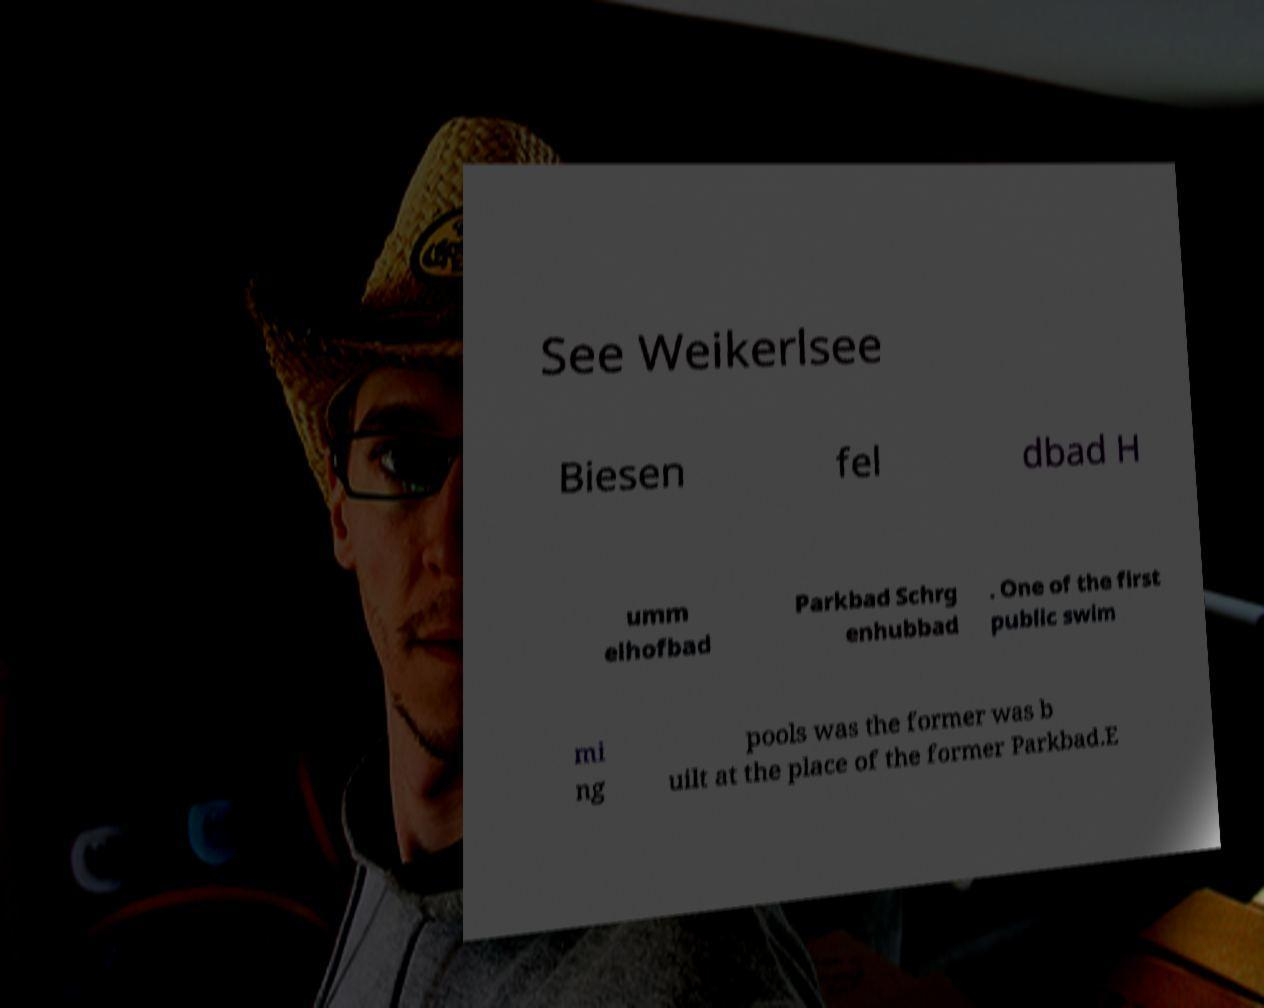Could you assist in decoding the text presented in this image and type it out clearly? See Weikerlsee Biesen fel dbad H umm elhofbad Parkbad Schrg enhubbad . One of the first public swim mi ng pools was the former was b uilt at the place of the former Parkbad.E 